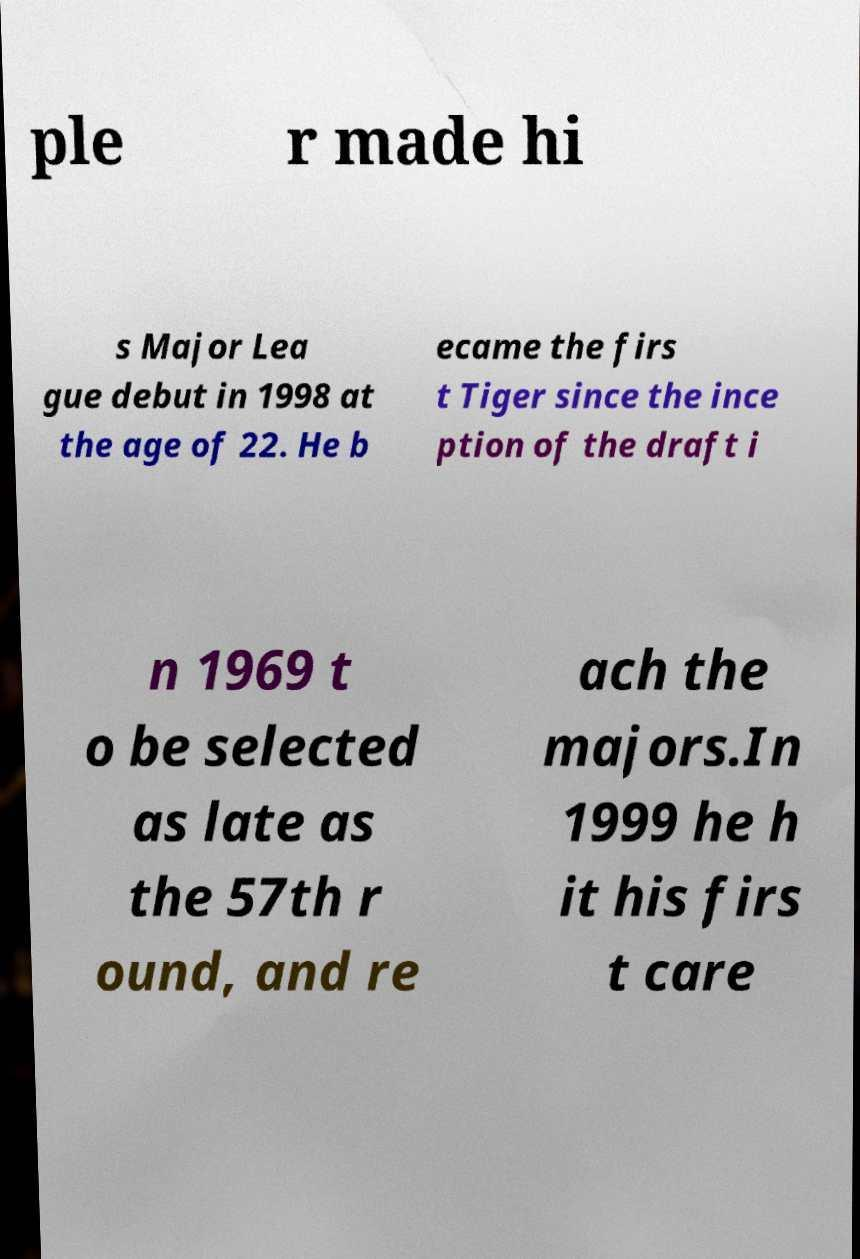Could you extract and type out the text from this image? ple r made hi s Major Lea gue debut in 1998 at the age of 22. He b ecame the firs t Tiger since the ince ption of the draft i n 1969 t o be selected as late as the 57th r ound, and re ach the majors.In 1999 he h it his firs t care 